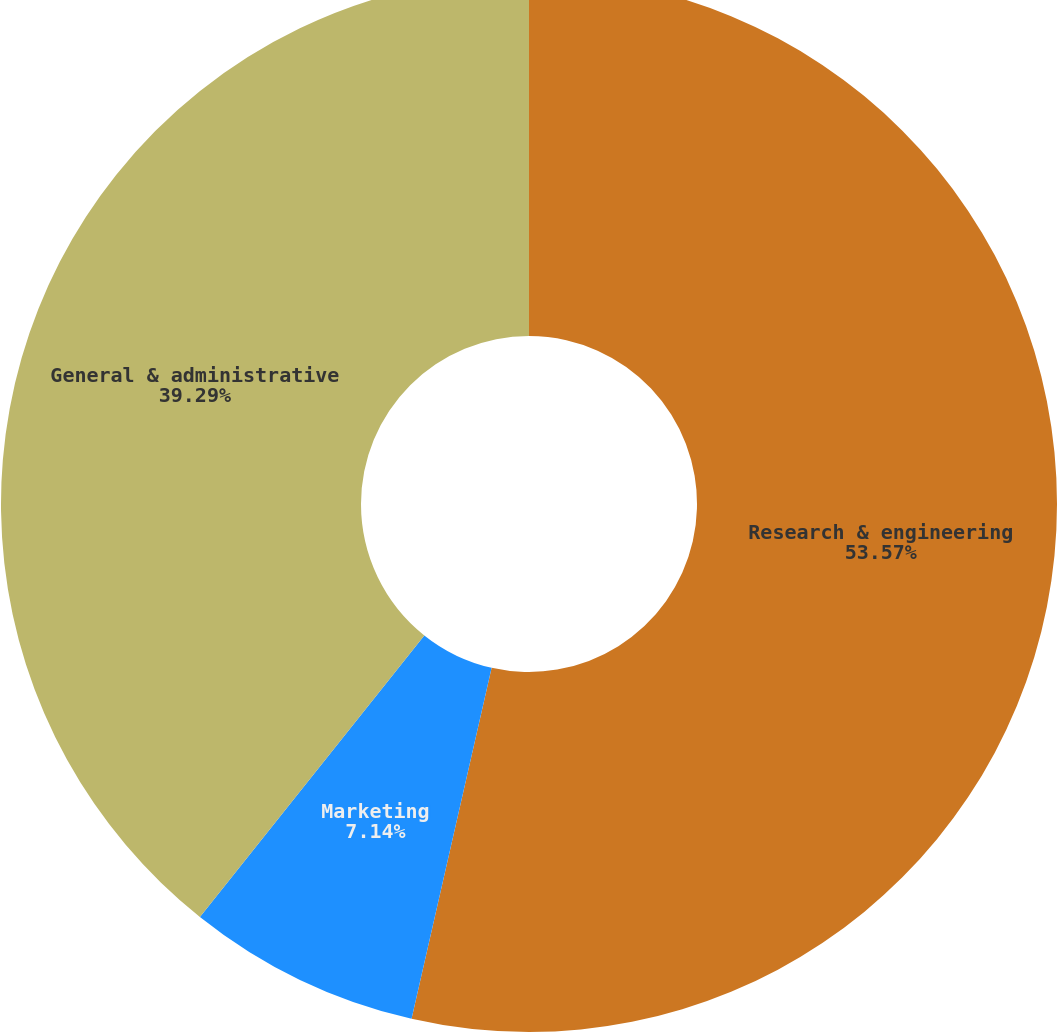Convert chart to OTSL. <chart><loc_0><loc_0><loc_500><loc_500><pie_chart><fcel>Research & engineering<fcel>Marketing<fcel>General & administrative<nl><fcel>53.57%<fcel>7.14%<fcel>39.29%<nl></chart> 